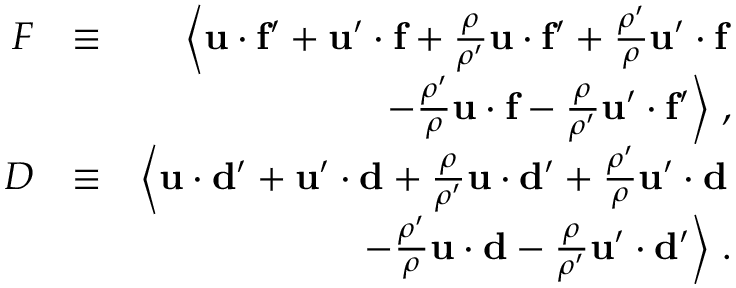<formula> <loc_0><loc_0><loc_500><loc_500>\begin{array} { r l r } { F } & { \equiv } & { \left \langle { u } \cdot { f ^ { \prime } } + { u } ^ { \prime } \cdot { f } + { \frac { \rho } { \rho ^ { \prime } } } { u } \cdot { f ^ { \prime } } + { \frac { \rho ^ { \prime } } { \rho } } { u } ^ { \prime } \cdot { f } } \\ & { - { \frac { \rho ^ { \prime } } { \rho } } { u } \cdot { f } - { \frac { \rho } { \rho ^ { \prime } } } { u } ^ { \prime } \cdot { f ^ { \prime } } \right \rangle \, , } \\ { D } & { \equiv } & { \left \langle { u } \cdot { d ^ { \prime } } + { u } ^ { \prime } \cdot { d } + { \frac { \rho } { \rho ^ { \prime } } } { u } \cdot { d ^ { \prime } } + { \frac { \rho ^ { \prime } } { \rho } } { u } ^ { \prime } \cdot { d } } \\ & { - { \frac { \rho ^ { \prime } } { \rho } } { u } \cdot { d } - { \frac { \rho } { \rho ^ { \prime } } } { u } ^ { \prime } \cdot { d ^ { \prime } } \right \rangle \, . } \end{array}</formula> 